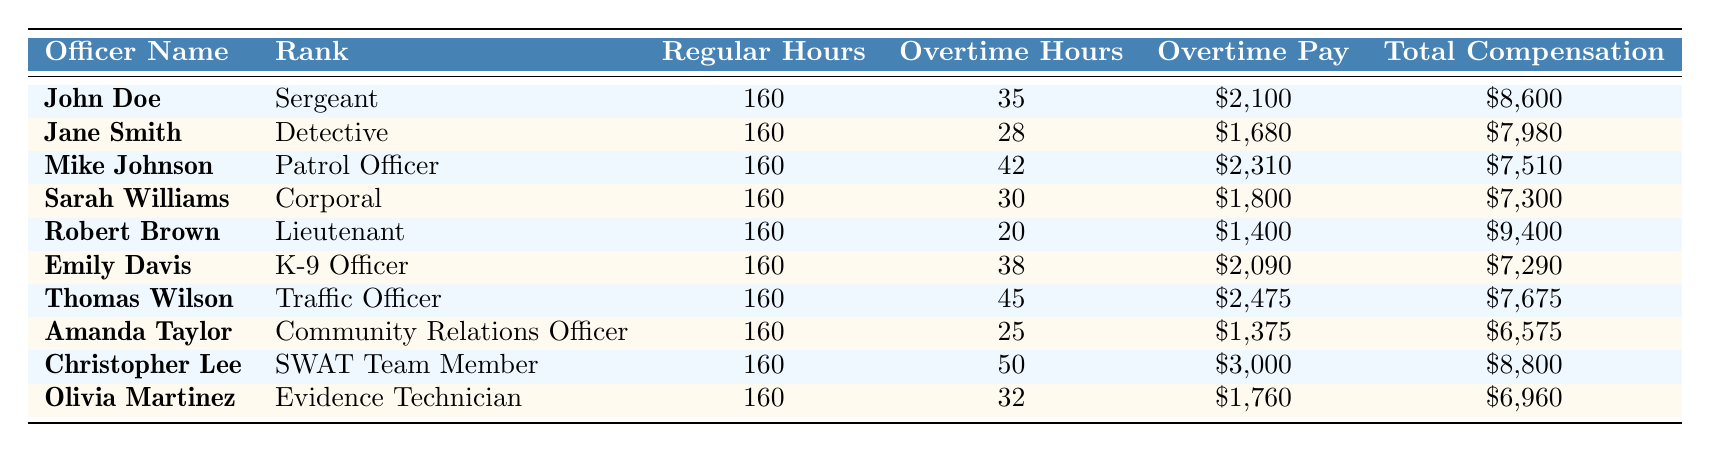What is the total compensation for John Doe? John Doe's total compensation is located in the last column next to his name. It is clearly stated as $8,600.
Answer: $8,600 Who has the highest overtime hours among the officers? By reviewing the "Overtime Hours" column, I compare each officer's hours. Christopher Lee has the highest number of overtime hours, totaling 50.
Answer: Christopher Lee What is the average overtime pay for the group of officers? First, I sum the overtime pay values: $2,100 + $1,680 + $2,310 + $1,800 + $1,400 + $2,090 + $2,475 + $1,375 + $3,000 + $1,760 = $19,090. Then I divide by the number of officers, which is 10, so the average is $19,090 / 10 = $1,909.
Answer: $1,909 Is Sarah Williams a higher-ranking officer than Thomas Wilson? Sarah Williams is a Corporal, while Thomas Wilson is a Traffic Officer. Since Corporal is ranked higher than Traffic Officer, the answer is yes.
Answer: Yes What is the difference between the total compensation of Christopher Lee and Amanda Taylor? Christopher Lee's total compensation is $8,800 and Amanda Taylor's total compensation is $6,575. The difference is $8,800 - $6,575 = $2,225.
Answer: $2,225 Which officer has the lowest total compensation? Looking at the "Total Compensation" column, I see that Amanda Taylor has the lowest amount at $6,575.
Answer: Amanda Taylor What are the total regular hours worked by all officers combined? Each officer works 160 regular hours. Since there are 10 officers, I multiply 160 hours by 10: 160 x 10 = 1,600 hours.
Answer: 1,600 hours Is the total compensation of Robert Brown greater than $9,000? Robert Brown's total compensation is stated as $9,400, which is indeed greater than $9,000.
Answer: Yes What is the total overtime pay for all officers combined? I add up the individual overtime pays: $2,100 + $1,680 + $2,310 + $1,800 + $1,400 + $2,090 + $2,475 + $1,375 + $3,000 + $1,760 = $19,090.
Answer: $19,090 